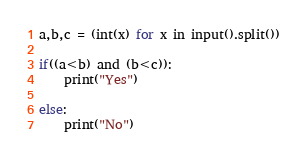Convert code to text. <code><loc_0><loc_0><loc_500><loc_500><_Python_>a,b,c = (int(x) for x in input().split())

if((a<b) and (b<c)):
    print("Yes")
    
else:
    print("No")
</code> 